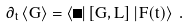Convert formula to latex. <formula><loc_0><loc_0><loc_500><loc_500>\partial _ { t } \, \langle G \rangle = \langle \Psi | \, [ G , L ] \, | F ( t ) \rangle \ .</formula> 